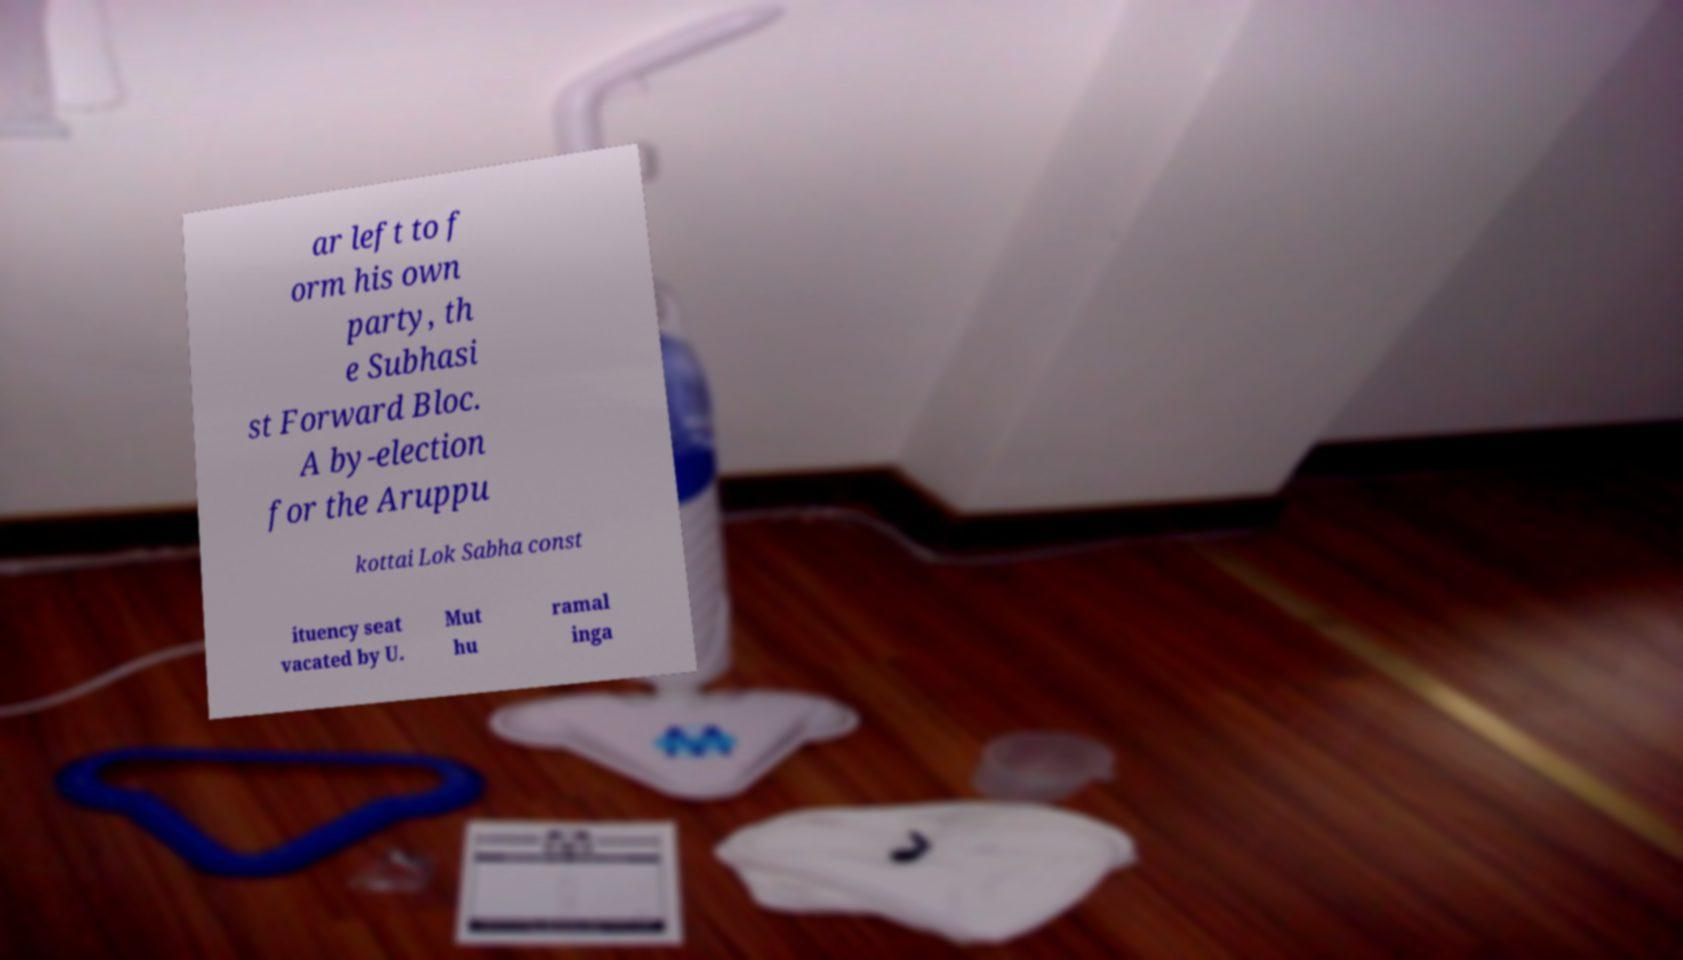Can you read and provide the text displayed in the image?This photo seems to have some interesting text. Can you extract and type it out for me? ar left to f orm his own party, th e Subhasi st Forward Bloc. A by-election for the Aruppu kottai Lok Sabha const ituency seat vacated by U. Mut hu ramal inga 